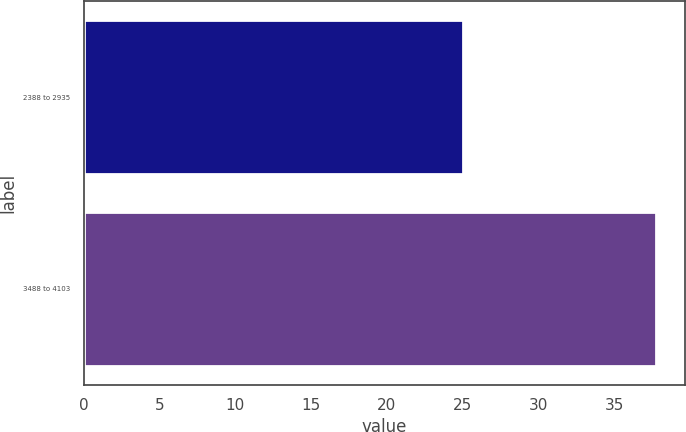Convert chart to OTSL. <chart><loc_0><loc_0><loc_500><loc_500><bar_chart><fcel>2388 to 2935<fcel>3488 to 4103<nl><fcel>25.06<fcel>37.79<nl></chart> 